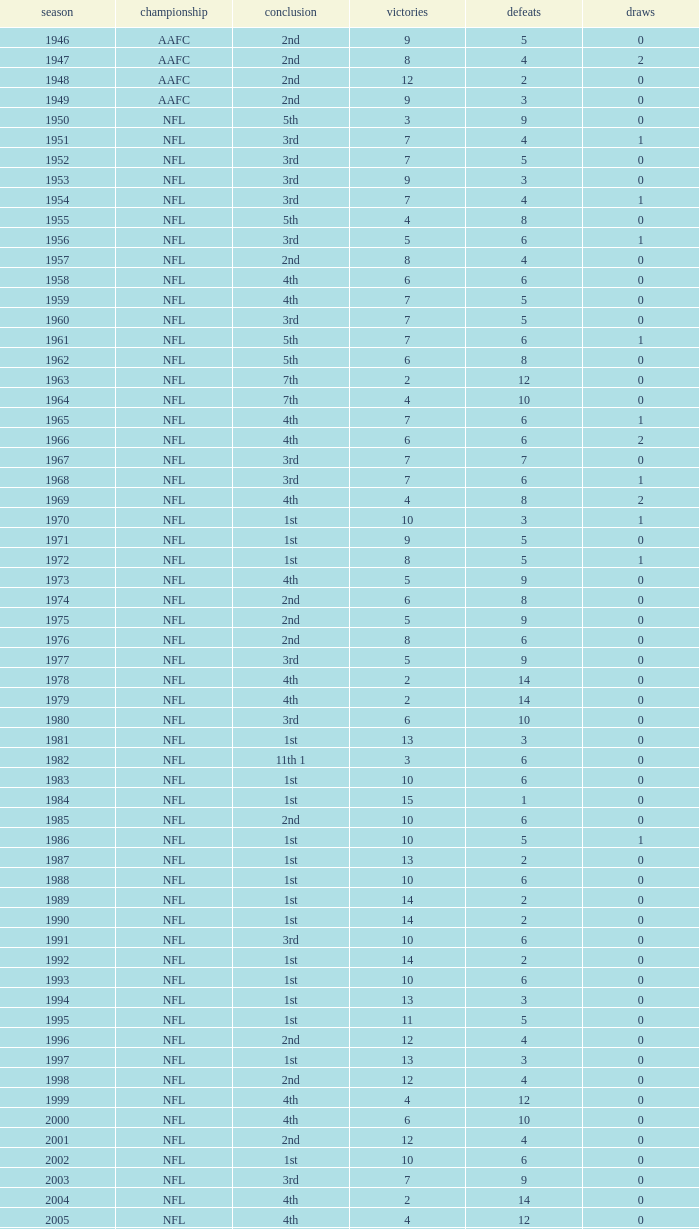What is the losses in the NFL in the 2011 season with less than 13 wins? None. 